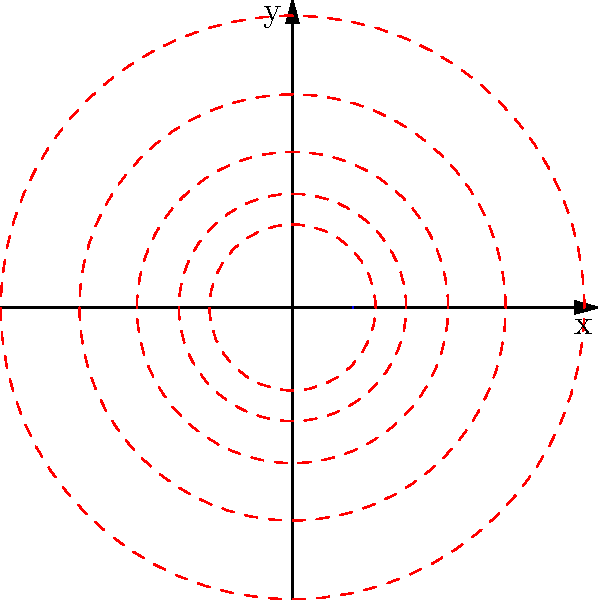In the context of sacred geometry, the spiral pattern shown above is inspired by the Golden Ratio. If the equation of this spiral is given by $r = ae^{b\theta}$, where $a = 0.1$ and $b = 0.05$, at what angle $\theta$ (in radians) will the radius of the spiral be exactly 1 unit? To find the angle $\theta$ where the radius is 1 unit, we follow these steps:

1) The equation of the spiral is $r = ae^{b\theta}$, where $a = 0.1$ and $b = 0.05$.

2) We want to find $\theta$ when $r = 1$, so we set up the equation:

   $1 = 0.1e^{0.05\theta}$

3) Divide both sides by 0.1:

   $10 = e^{0.05\theta}$

4) Take the natural log of both sides:

   $\ln(10) = 0.05\theta$

5) Solve for $\theta$:

   $\theta = \frac{\ln(10)}{0.05}$

6) Calculate the value:

   $\theta = \frac{2.30258509...}{0.05} \approx 46.0517$ radians

This angle represents approximately 7.33 full rotations around the origin, reflecting the expansive nature of spiritual growth and the interconnectedness in sacred geometry.
Answer: $\frac{\ln(10)}{0.05}$ radians 